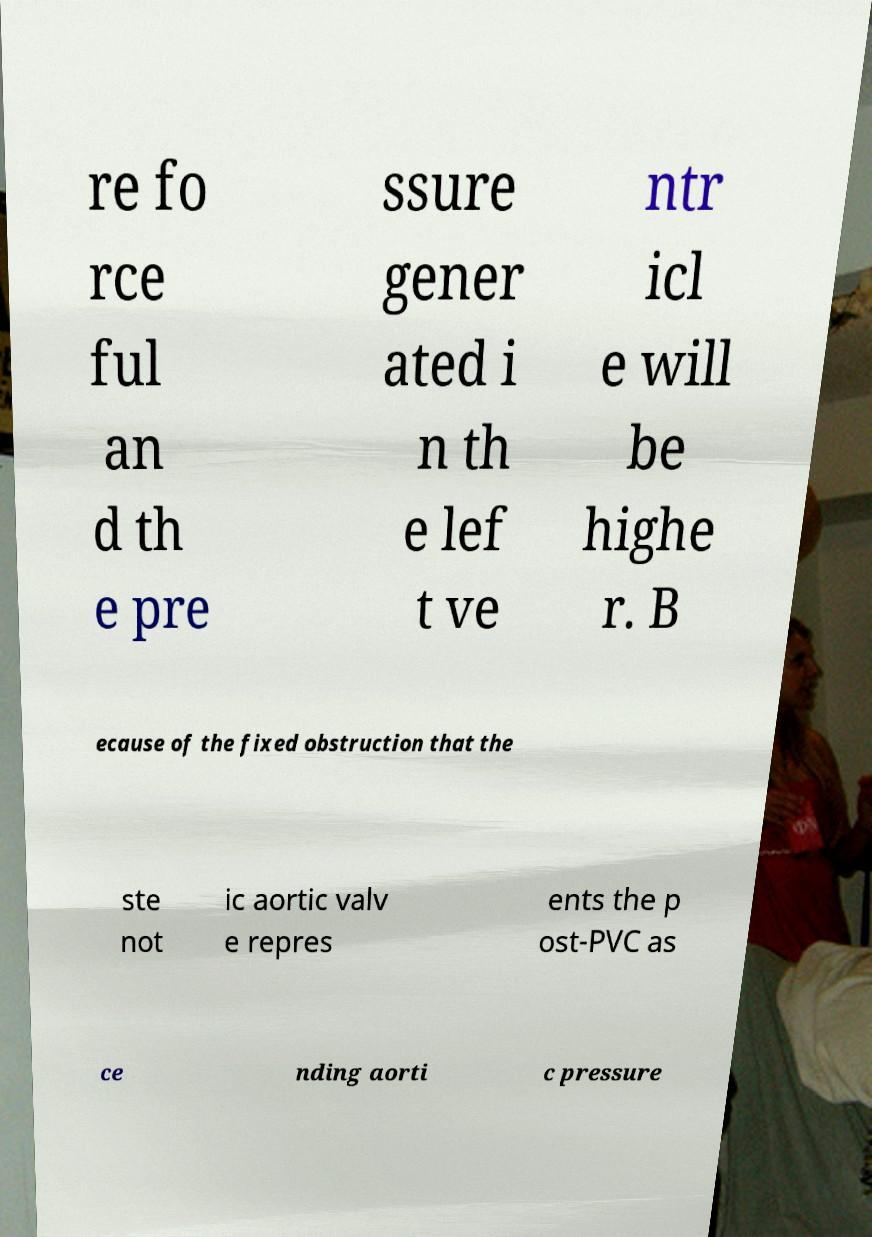Could you extract and type out the text from this image? re fo rce ful an d th e pre ssure gener ated i n th e lef t ve ntr icl e will be highe r. B ecause of the fixed obstruction that the ste not ic aortic valv e repres ents the p ost-PVC as ce nding aorti c pressure 